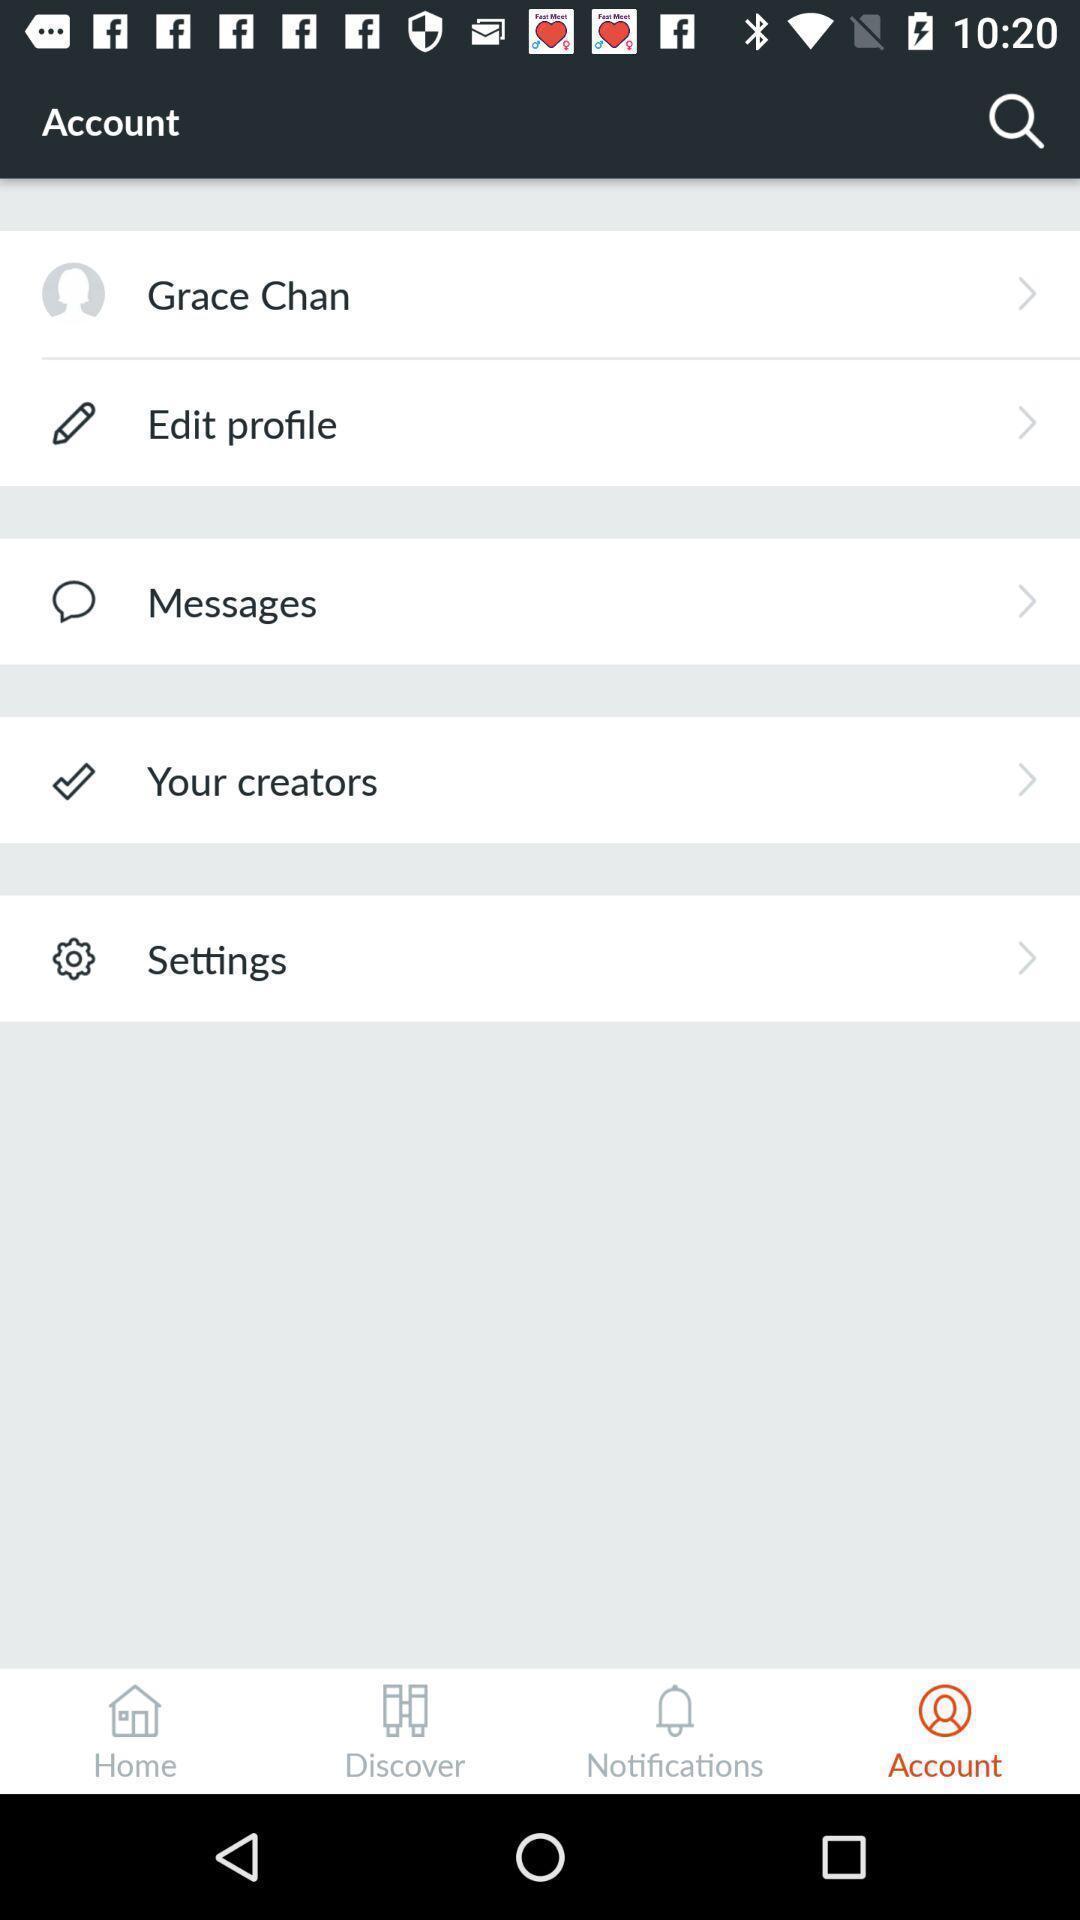Summarize the information in this screenshot. Screen showing account info page of a social media app. 